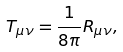<formula> <loc_0><loc_0><loc_500><loc_500>T _ { \mu \nu } = \frac { 1 } { 8 \pi } R _ { \mu \nu } ,</formula> 